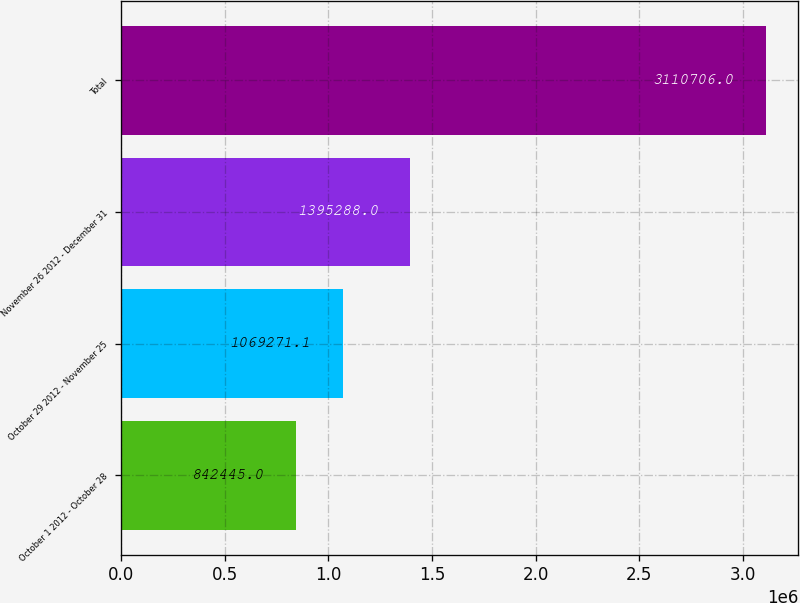<chart> <loc_0><loc_0><loc_500><loc_500><bar_chart><fcel>October 1 2012 - October 28<fcel>October 29 2012 - November 25<fcel>November 26 2012 - December 31<fcel>Total<nl><fcel>842445<fcel>1.06927e+06<fcel>1.39529e+06<fcel>3.11071e+06<nl></chart> 